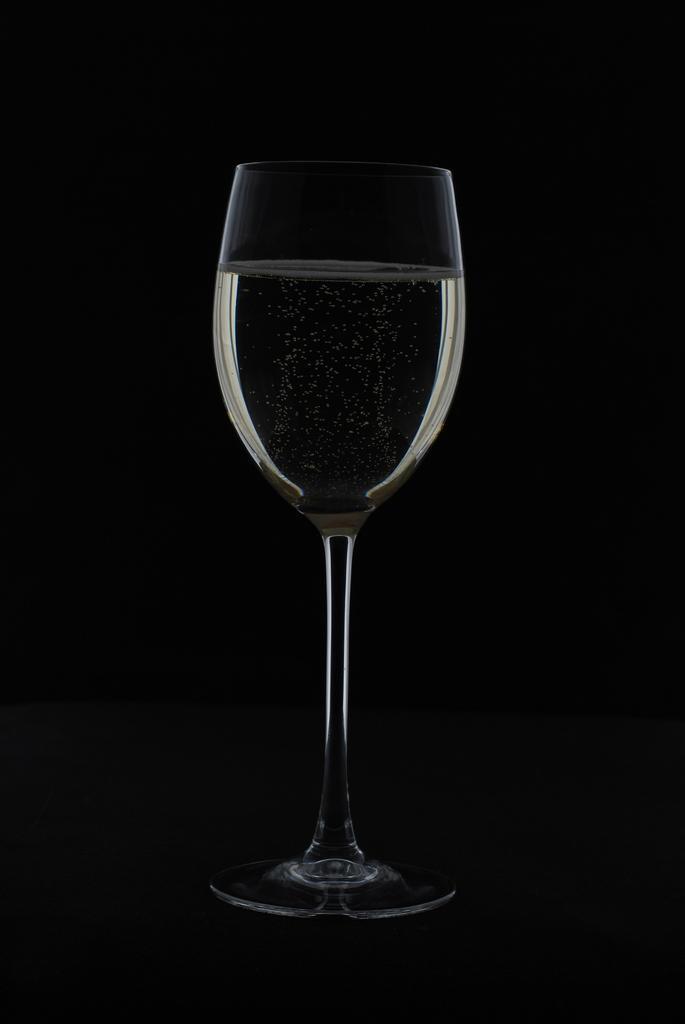How would you summarize this image in a sentence or two? In this picture there is a glass of juice in the center of the image. 